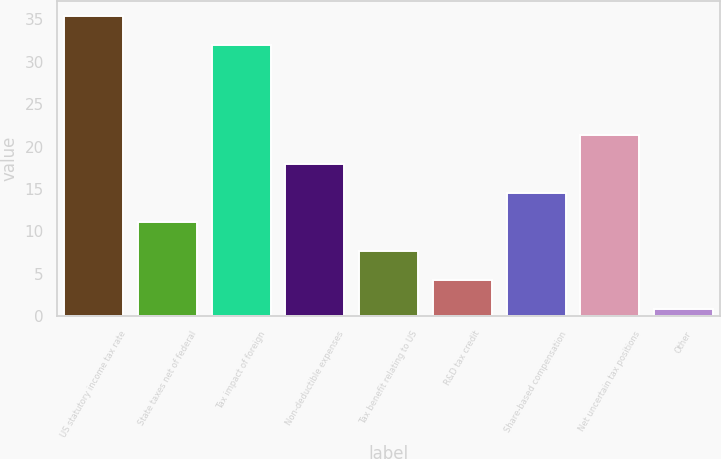Convert chart. <chart><loc_0><loc_0><loc_500><loc_500><bar_chart><fcel>US statutory income tax rate<fcel>State taxes net of federal<fcel>Tax impact of foreign<fcel>Non-deductible expenses<fcel>Tax benefit relating to US<fcel>R&D tax credit<fcel>Share-based compensation<fcel>Net uncertain tax positions<fcel>Other<nl><fcel>35.42<fcel>11.06<fcel>32<fcel>17.9<fcel>7.64<fcel>4.22<fcel>14.48<fcel>21.32<fcel>0.8<nl></chart> 